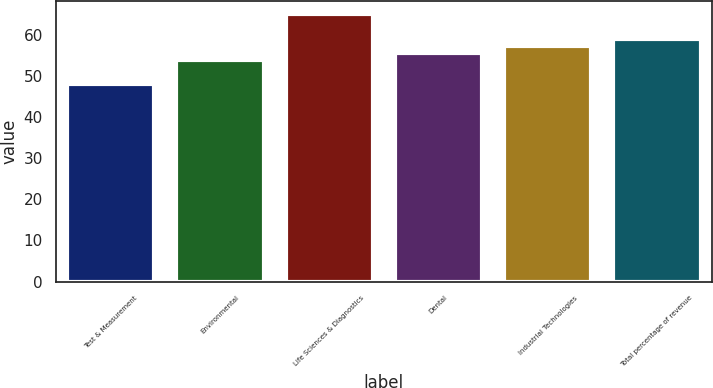Convert chart to OTSL. <chart><loc_0><loc_0><loc_500><loc_500><bar_chart><fcel>Test & Measurement<fcel>Environmental<fcel>Life Sciences & Diagnostics<fcel>Dental<fcel>Industrial Technologies<fcel>Total percentage of revenue<nl><fcel>48<fcel>54<fcel>65<fcel>55.7<fcel>57.4<fcel>59.1<nl></chart> 